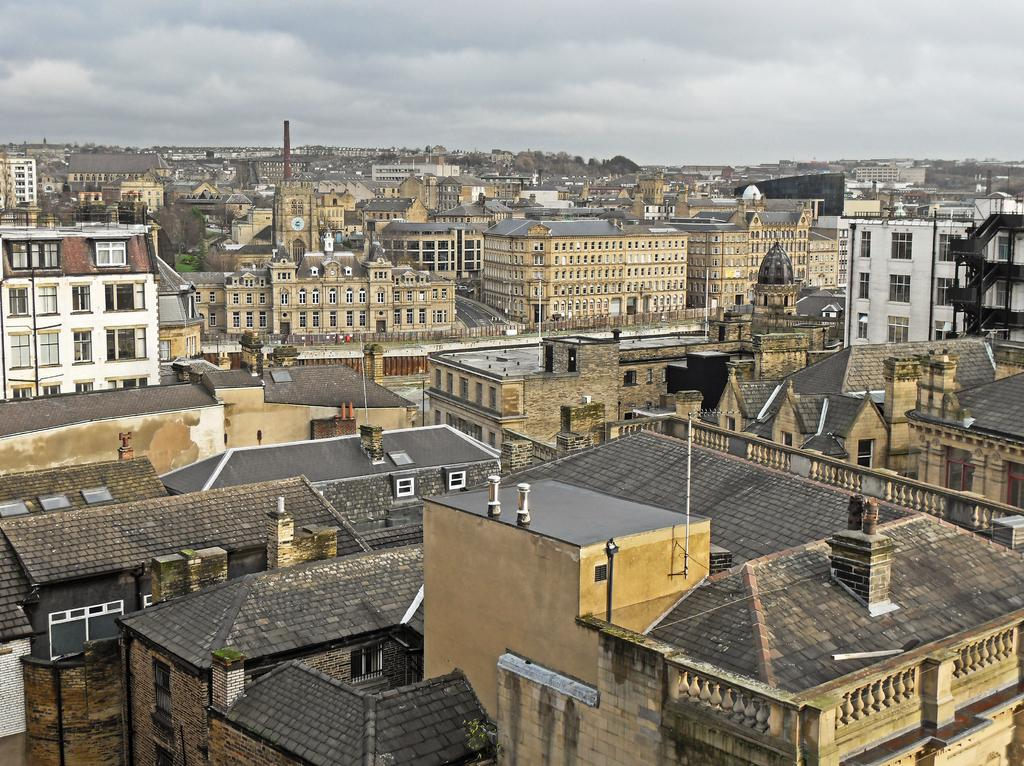What type of structures can be seen in the image? There are many buildings in the image. What other natural elements are present in the image? There are trees and plants in the image. What are the poles used for in the image? The poles are likely used for supporting wires or other infrastructure. What is on the buildings in the image? There are objects on the buildings, such as signs or decorations. Can you describe the board on one of the buildings? The board on one of the buildings might be a sign or advertisement. What is visible at the top of the image? The sky is visible at the top of the image. How many legs can be seen on the buildings in the image? Buildings do not have legs; they are stationary structures. What type of trade is being conducted in the image? There is no indication of any trade or commerce taking place in the image. 